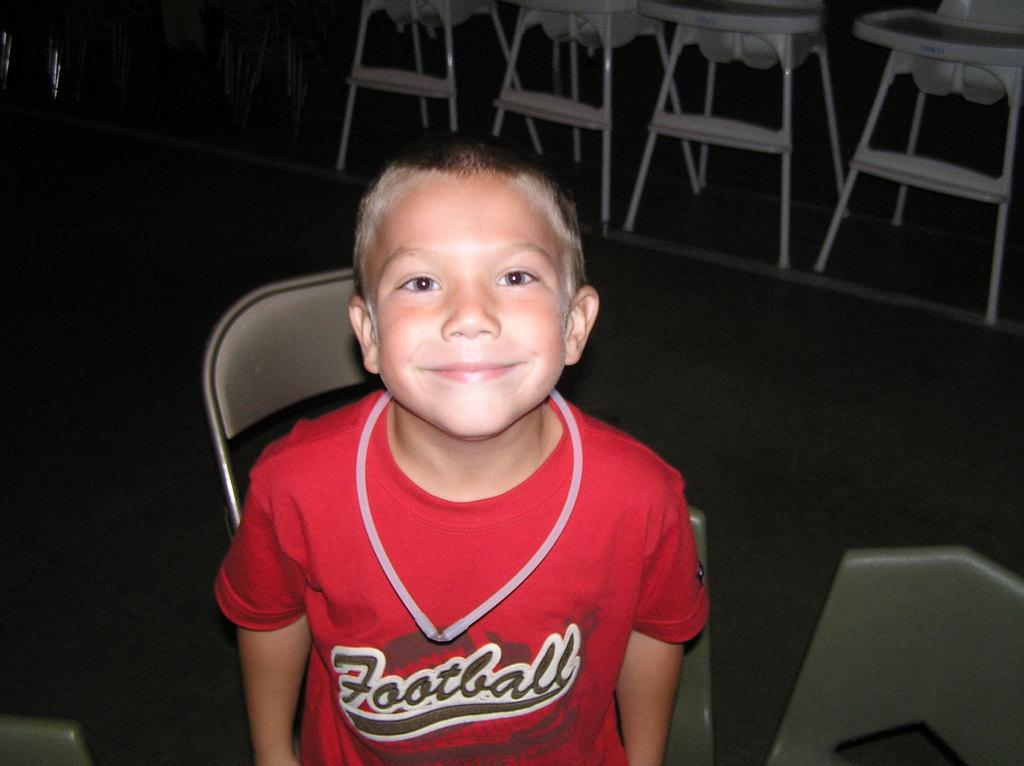<image>
Create a compact narrative representing the image presented. A smiling little boys who clearly likes football. 